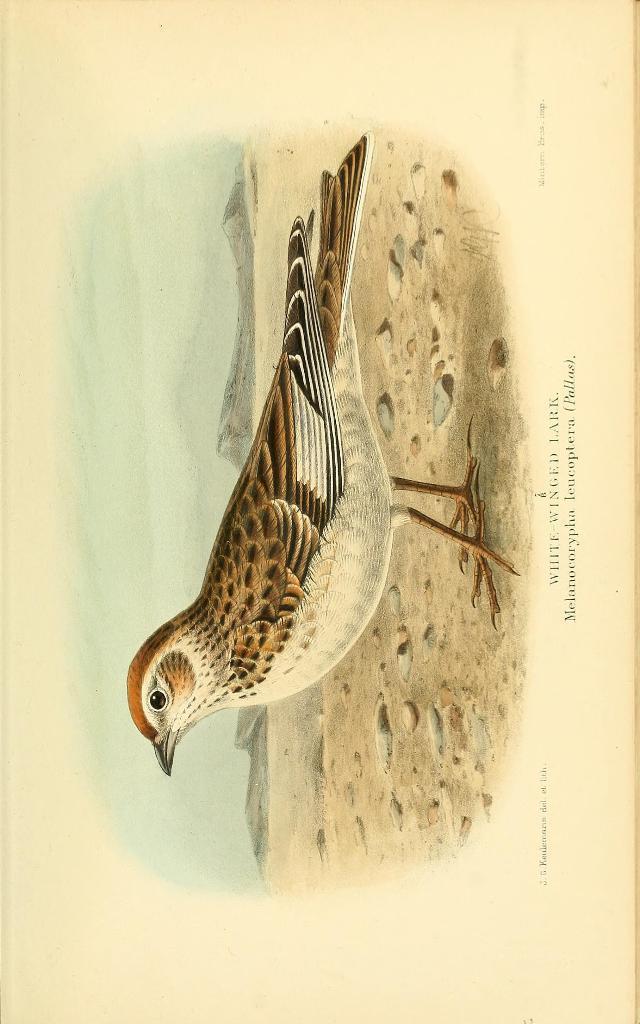Describe this image in one or two sentences. In this image we can see the picture of a bird on the ground. We can also see some text on this image. 